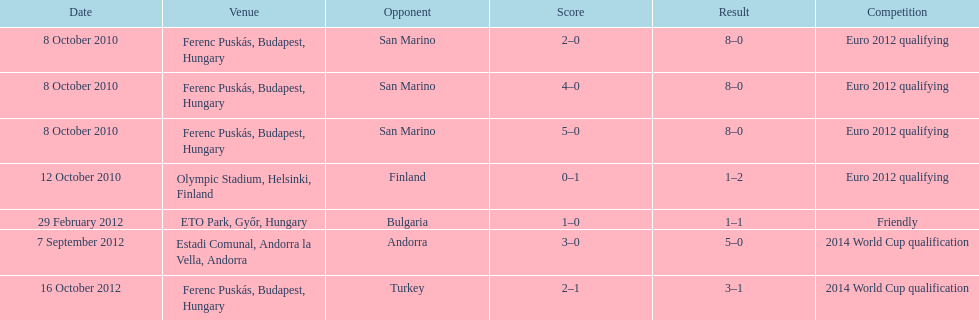In what year was szalai's first international goal? 2010. 